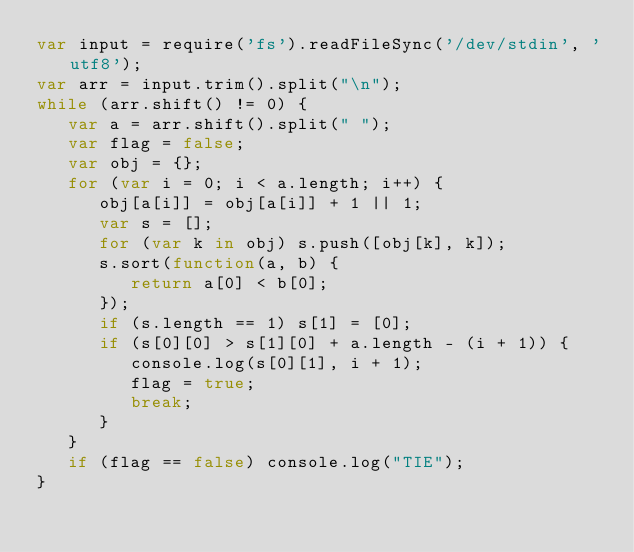<code> <loc_0><loc_0><loc_500><loc_500><_JavaScript_>var input = require('fs').readFileSync('/dev/stdin', 'utf8');
var arr = input.trim().split("\n");
while (arr.shift() != 0) {
   var a = arr.shift().split(" ");
   var flag = false;
   var obj = {};
   for (var i = 0; i < a.length; i++) {
      obj[a[i]] = obj[a[i]] + 1 || 1;
      var s = [];
      for (var k in obj) s.push([obj[k], k]);
      s.sort(function(a, b) {
         return a[0] < b[0];
      });
      if (s.length == 1) s[1] = [0];
      if (s[0][0] > s[1][0] + a.length - (i + 1)) {
         console.log(s[0][1], i + 1);
         flag = true;
         break;
      }
   }
   if (flag == false) console.log("TIE");
}</code> 